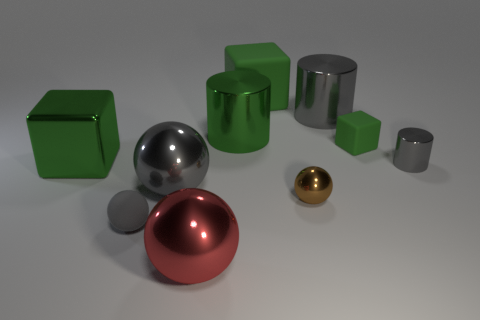Subtract all blocks. How many objects are left? 7 Subtract 0 purple cubes. How many objects are left? 10 Subtract all small gray cylinders. Subtract all big green blocks. How many objects are left? 7 Add 7 big red objects. How many big red objects are left? 8 Add 9 large green matte things. How many large green matte things exist? 10 